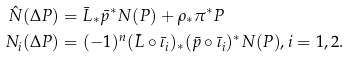Convert formula to latex. <formula><loc_0><loc_0><loc_500><loc_500>\hat { N } ( \Delta P ) & = \bar { L } _ { * } \bar { p } ^ { * } N ( P ) + \rho _ { * } \pi ^ { * } P \\ N _ { i } ( \Delta P ) & = ( - 1 ) ^ { n } ( \bar { L } \circ \bar { \iota } _ { i } ) _ { * } ( \bar { p } \circ \bar { \iota } _ { i } ) ^ { * } N ( P ) , i = 1 , 2 .</formula> 